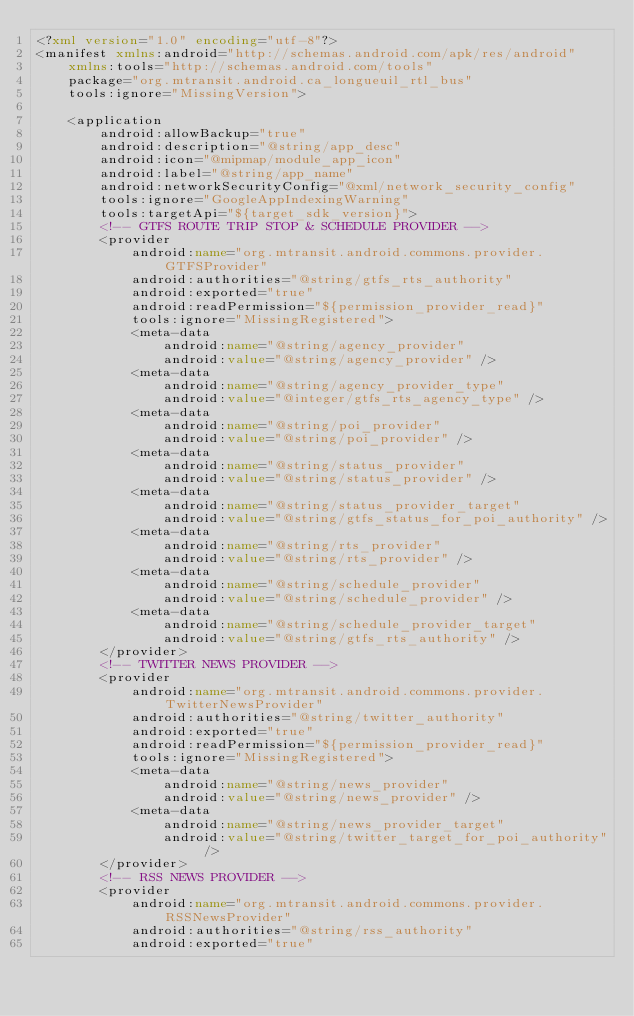Convert code to text. <code><loc_0><loc_0><loc_500><loc_500><_XML_><?xml version="1.0" encoding="utf-8"?>
<manifest xmlns:android="http://schemas.android.com/apk/res/android"
    xmlns:tools="http://schemas.android.com/tools"
    package="org.mtransit.android.ca_longueuil_rtl_bus"
    tools:ignore="MissingVersion">

    <application
        android:allowBackup="true"
        android:description="@string/app_desc"
        android:icon="@mipmap/module_app_icon"
        android:label="@string/app_name"
        android:networkSecurityConfig="@xml/network_security_config"
        tools:ignore="GoogleAppIndexingWarning"
        tools:targetApi="${target_sdk_version}">
        <!-- GTFS ROUTE TRIP STOP & SCHEDULE PROVIDER -->
        <provider
            android:name="org.mtransit.android.commons.provider.GTFSProvider"
            android:authorities="@string/gtfs_rts_authority"
            android:exported="true"
            android:readPermission="${permission_provider_read}"
            tools:ignore="MissingRegistered">
            <meta-data
                android:name="@string/agency_provider"
                android:value="@string/agency_provider" />
            <meta-data
                android:name="@string/agency_provider_type"
                android:value="@integer/gtfs_rts_agency_type" />
            <meta-data
                android:name="@string/poi_provider"
                android:value="@string/poi_provider" />
            <meta-data
                android:name="@string/status_provider"
                android:value="@string/status_provider" />
            <meta-data
                android:name="@string/status_provider_target"
                android:value="@string/gtfs_status_for_poi_authority" />
            <meta-data
                android:name="@string/rts_provider"
                android:value="@string/rts_provider" />
            <meta-data
                android:name="@string/schedule_provider"
                android:value="@string/schedule_provider" />
            <meta-data
                android:name="@string/schedule_provider_target"
                android:value="@string/gtfs_rts_authority" />
        </provider>
        <!-- TWITTER NEWS PROVIDER -->
        <provider
            android:name="org.mtransit.android.commons.provider.TwitterNewsProvider"
            android:authorities="@string/twitter_authority"
            android:exported="true"
            android:readPermission="${permission_provider_read}"
            tools:ignore="MissingRegistered">
            <meta-data
                android:name="@string/news_provider"
                android:value="@string/news_provider" />
            <meta-data
                android:name="@string/news_provider_target"
                android:value="@string/twitter_target_for_poi_authority" />
        </provider>
        <!-- RSS NEWS PROVIDER -->
        <provider
            android:name="org.mtransit.android.commons.provider.RSSNewsProvider"
            android:authorities="@string/rss_authority"
            android:exported="true"</code> 